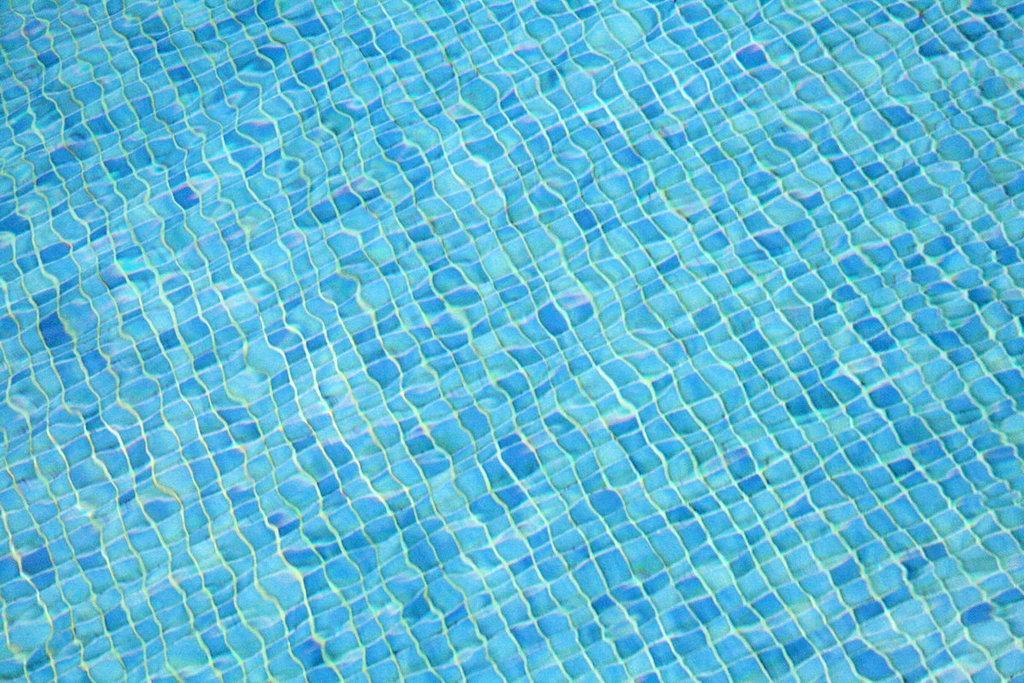Please provide a concise description of this image. In this picture we can see water, surface with tiles of dark and light blue colors. 